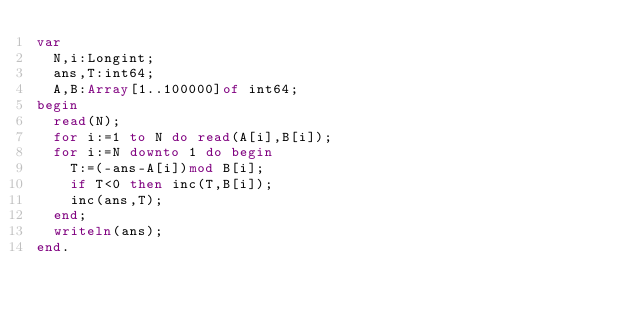Convert code to text. <code><loc_0><loc_0><loc_500><loc_500><_Pascal_>var
	N,i:Longint;
	ans,T:int64;
	A,B:Array[1..100000]of int64;
begin
	read(N);
	for i:=1 to N do read(A[i],B[i]);
	for i:=N downto 1 do begin
		T:=(-ans-A[i])mod B[i];
		if T<0 then inc(T,B[i]);
		inc(ans,T);
	end;
	writeln(ans);
end.
</code> 